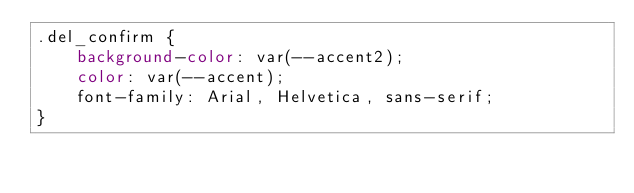Convert code to text. <code><loc_0><loc_0><loc_500><loc_500><_CSS_>.del_confirm {
    background-color: var(--accent2);
    color: var(--accent);
    font-family: Arial, Helvetica, sans-serif;
}</code> 